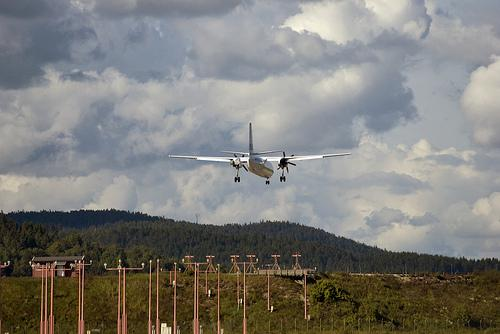Question: what is flying through the air?
Choices:
A. Kite.
B. Plane.
C. Birds.
D. Ball.
Answer with the letter. Answer: B Question: where was the photo taken?
Choices:
A. Train station.
B. Parking lot.
C. Subway.
D. At the airport.
Answer with the letter. Answer: D Question: what is in the background?
Choices:
A. Sky.
B. Hills.
C. Buildings.
D. Trees.
Answer with the letter. Answer: B 